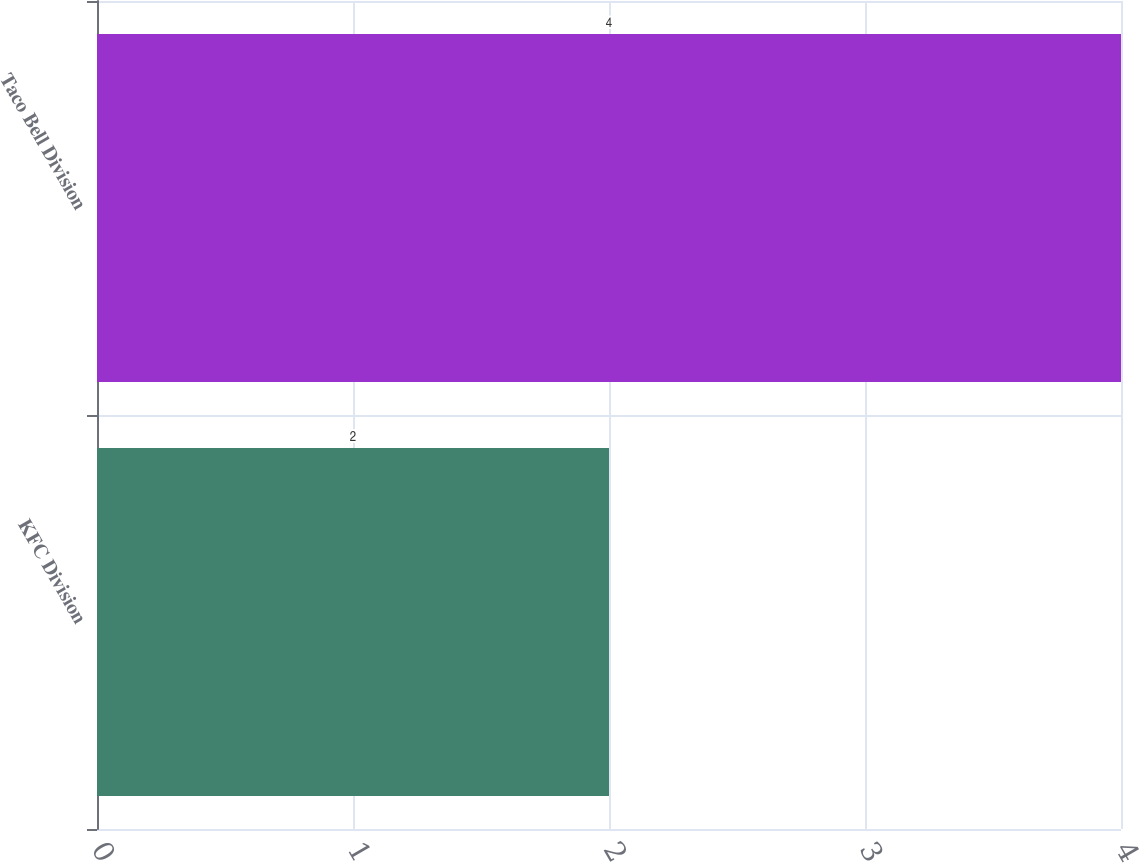Convert chart. <chart><loc_0><loc_0><loc_500><loc_500><bar_chart><fcel>KFC Division<fcel>Taco Bell Division<nl><fcel>2<fcel>4<nl></chart> 